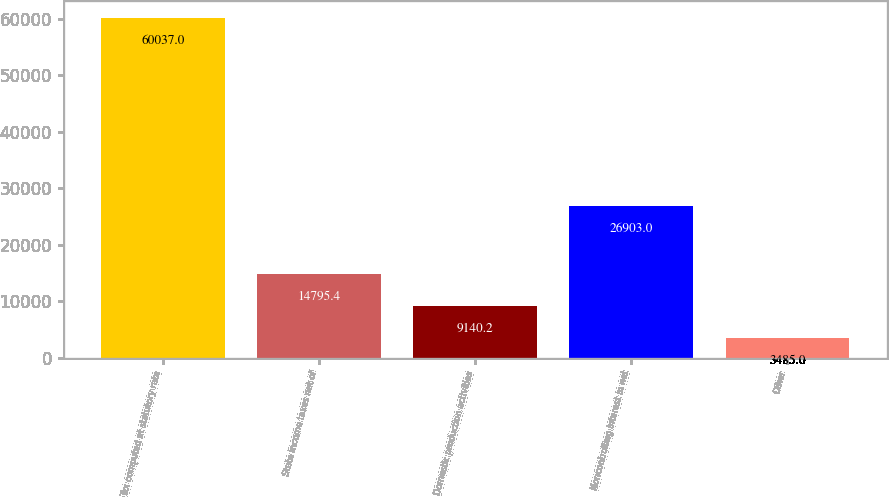Convert chart. <chart><loc_0><loc_0><loc_500><loc_500><bar_chart><fcel>Tax computed at statutory rate<fcel>State income taxes net of<fcel>Domestic production activities<fcel>Noncontrolling interest in net<fcel>Other<nl><fcel>60037<fcel>14795.4<fcel>9140.2<fcel>26903<fcel>3485<nl></chart> 